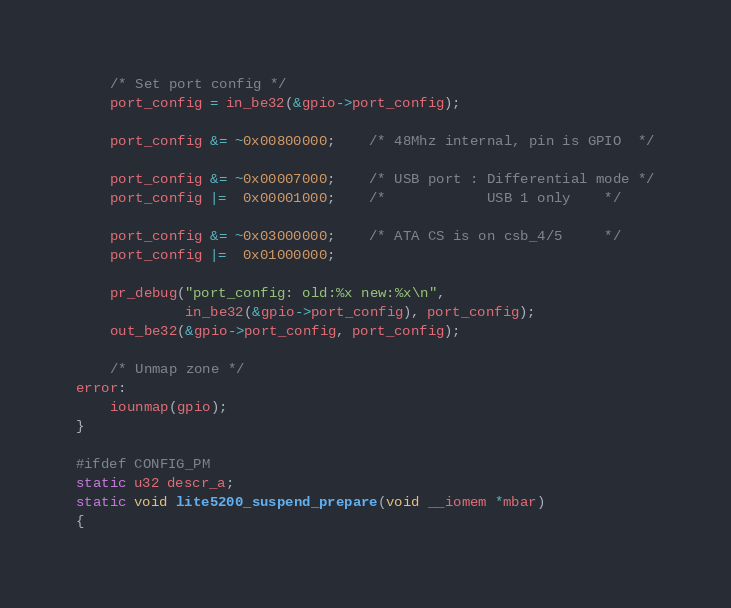<code> <loc_0><loc_0><loc_500><loc_500><_C_>	/* Set port config */
	port_config = in_be32(&gpio->port_config);

	port_config &= ~0x00800000;	/* 48Mhz internal, pin is GPIO	*/

	port_config &= ~0x00007000;	/* USB port : Differential mode	*/
	port_config |=  0x00001000;	/*            USB 1 only	*/

	port_config &= ~0x03000000;	/* ATA CS is on csb_4/5		*/
	port_config |=  0x01000000;

	pr_debug("port_config: old:%x new:%x\n",
	         in_be32(&gpio->port_config), port_config);
	out_be32(&gpio->port_config, port_config);

	/* Unmap zone */
error:
	iounmap(gpio);
}

#ifdef CONFIG_PM
static u32 descr_a;
static void lite5200_suspend_prepare(void __iomem *mbar)
{</code> 